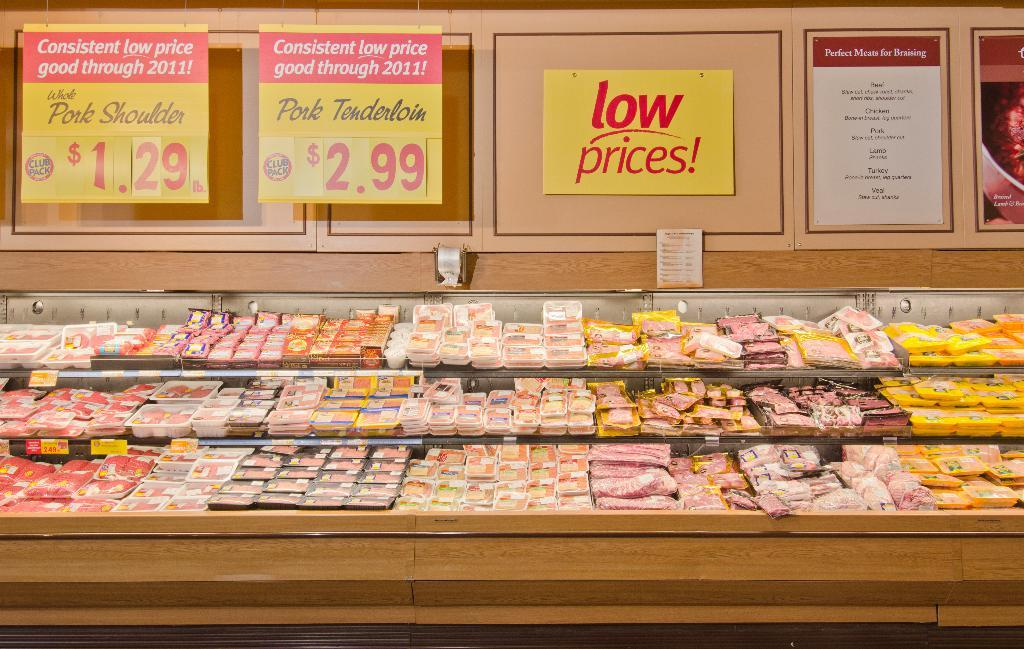<image>
Provide a brief description of the given image. Meat display shelves with a low prices! sign on them 